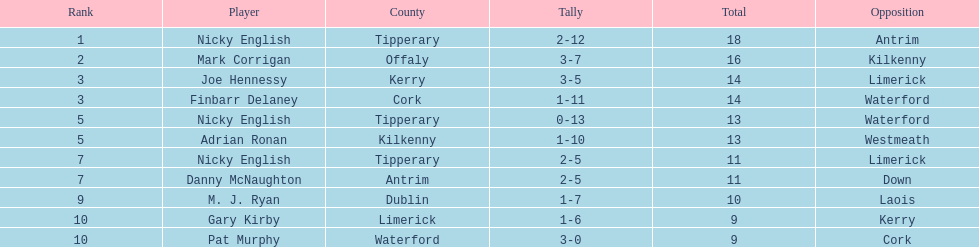What was the mean of the combined sums of nicky english and mark corrigan? 17. 